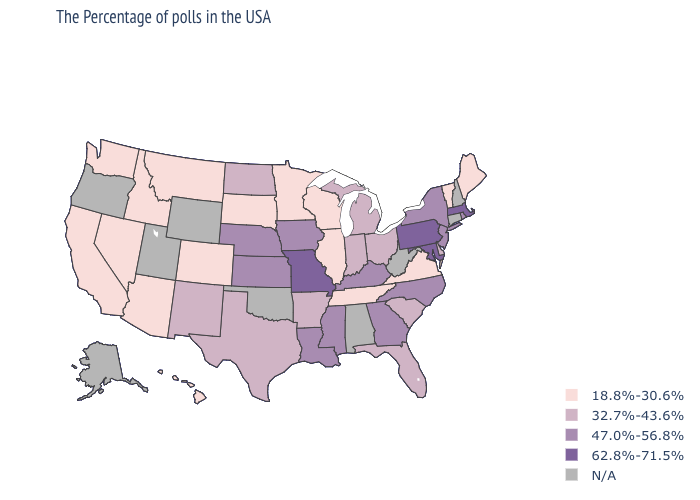Among the states that border New Mexico , which have the lowest value?
Give a very brief answer. Colorado, Arizona. Among the states that border New Mexico , which have the highest value?
Give a very brief answer. Texas. Is the legend a continuous bar?
Short answer required. No. Does South Dakota have the highest value in the USA?
Be succinct. No. What is the value of South Carolina?
Answer briefly. 32.7%-43.6%. What is the value of Oregon?
Give a very brief answer. N/A. What is the value of Oregon?
Keep it brief. N/A. Which states have the highest value in the USA?
Write a very short answer. Massachusetts, Maryland, Pennsylvania, Missouri. Name the states that have a value in the range 47.0%-56.8%?
Be succinct. Rhode Island, New York, New Jersey, North Carolina, Georgia, Kentucky, Mississippi, Louisiana, Iowa, Kansas, Nebraska. Which states have the lowest value in the South?
Write a very short answer. Virginia, Tennessee. Is the legend a continuous bar?
Keep it brief. No. Among the states that border Minnesota , which have the lowest value?
Answer briefly. Wisconsin, South Dakota. Which states have the highest value in the USA?
Concise answer only. Massachusetts, Maryland, Pennsylvania, Missouri. What is the value of Wyoming?
Give a very brief answer. N/A. Name the states that have a value in the range N/A?
Write a very short answer. New Hampshire, Connecticut, West Virginia, Alabama, Oklahoma, Wyoming, Utah, Oregon, Alaska. 